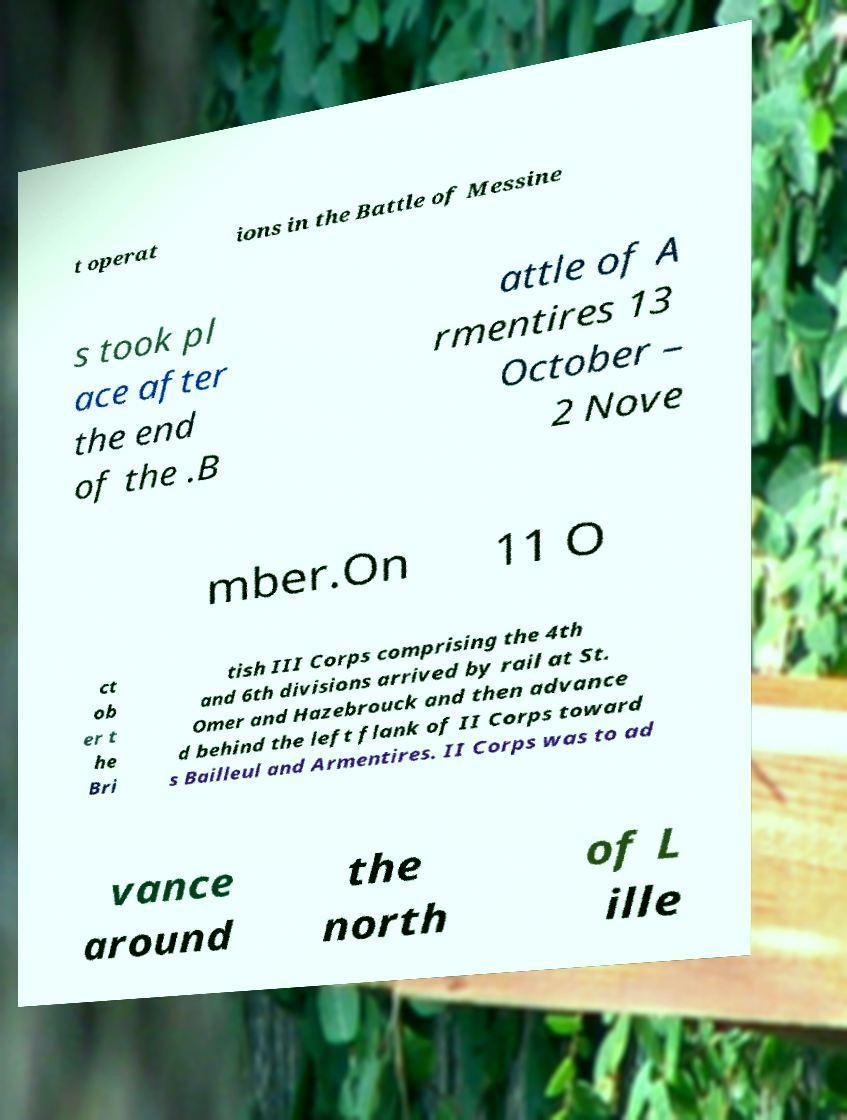Please read and relay the text visible in this image. What does it say? t operat ions in the Battle of Messine s took pl ace after the end of the .B attle of A rmentires 13 October – 2 Nove mber.On 11 O ct ob er t he Bri tish III Corps comprising the 4th and 6th divisions arrived by rail at St. Omer and Hazebrouck and then advance d behind the left flank of II Corps toward s Bailleul and Armentires. II Corps was to ad vance around the north of L ille 